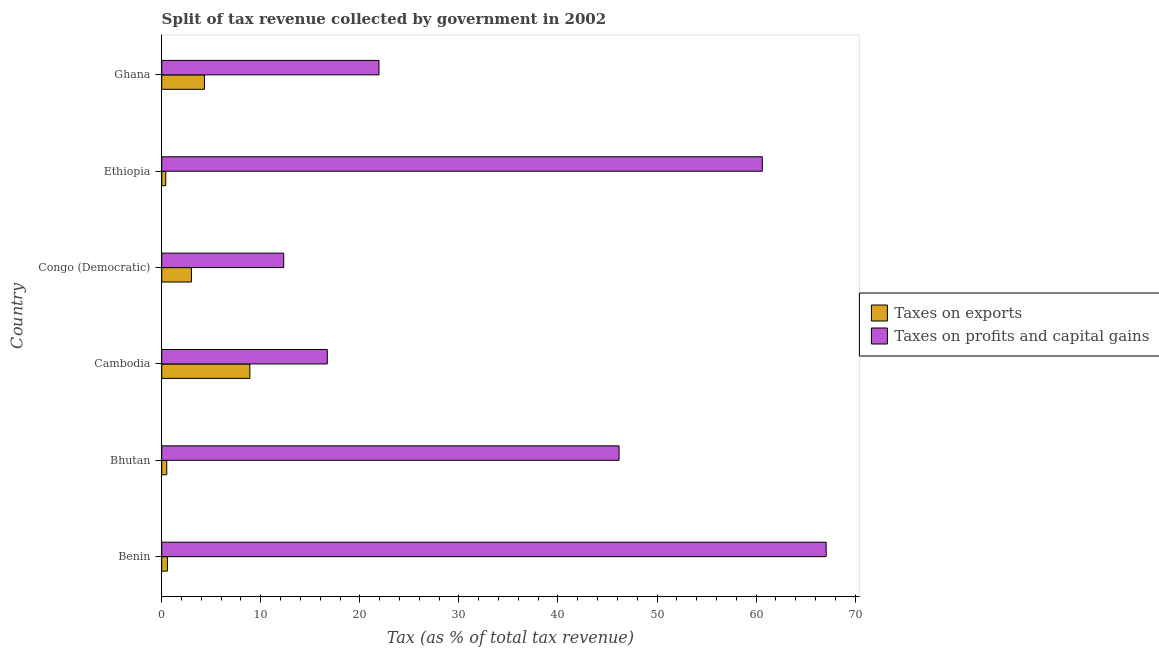How many different coloured bars are there?
Your answer should be compact. 2. Are the number of bars per tick equal to the number of legend labels?
Keep it short and to the point. Yes. Are the number of bars on each tick of the Y-axis equal?
Your response must be concise. Yes. What is the label of the 2nd group of bars from the top?
Offer a terse response. Ethiopia. In how many cases, is the number of bars for a given country not equal to the number of legend labels?
Offer a very short reply. 0. What is the percentage of revenue obtained from taxes on exports in Cambodia?
Provide a succinct answer. 8.9. Across all countries, what is the maximum percentage of revenue obtained from taxes on profits and capital gains?
Ensure brevity in your answer.  67.07. Across all countries, what is the minimum percentage of revenue obtained from taxes on exports?
Provide a succinct answer. 0.41. In which country was the percentage of revenue obtained from taxes on profits and capital gains maximum?
Give a very brief answer. Benin. In which country was the percentage of revenue obtained from taxes on exports minimum?
Keep it short and to the point. Ethiopia. What is the total percentage of revenue obtained from taxes on exports in the graph?
Make the answer very short. 17.71. What is the difference between the percentage of revenue obtained from taxes on profits and capital gains in Ethiopia and that in Ghana?
Offer a very short reply. 38.7. What is the difference between the percentage of revenue obtained from taxes on profits and capital gains in Benin and the percentage of revenue obtained from taxes on exports in Cambodia?
Your answer should be very brief. 58.18. What is the average percentage of revenue obtained from taxes on exports per country?
Provide a short and direct response. 2.95. What is the difference between the percentage of revenue obtained from taxes on profits and capital gains and percentage of revenue obtained from taxes on exports in Ghana?
Give a very brief answer. 17.62. What is the ratio of the percentage of revenue obtained from taxes on profits and capital gains in Cambodia to that in Congo (Democratic)?
Your answer should be very brief. 1.36. Is the difference between the percentage of revenue obtained from taxes on profits and capital gains in Benin and Ghana greater than the difference between the percentage of revenue obtained from taxes on exports in Benin and Ghana?
Offer a terse response. Yes. What is the difference between the highest and the second highest percentage of revenue obtained from taxes on profits and capital gains?
Your answer should be compact. 6.44. What is the difference between the highest and the lowest percentage of revenue obtained from taxes on exports?
Offer a terse response. 8.49. In how many countries, is the percentage of revenue obtained from taxes on profits and capital gains greater than the average percentage of revenue obtained from taxes on profits and capital gains taken over all countries?
Your answer should be very brief. 3. What does the 1st bar from the top in Cambodia represents?
Your answer should be compact. Taxes on profits and capital gains. What does the 2nd bar from the bottom in Cambodia represents?
Your answer should be very brief. Taxes on profits and capital gains. How many bars are there?
Ensure brevity in your answer.  12. Are all the bars in the graph horizontal?
Ensure brevity in your answer.  Yes. How many countries are there in the graph?
Keep it short and to the point. 6. Are the values on the major ticks of X-axis written in scientific E-notation?
Keep it short and to the point. No. Does the graph contain any zero values?
Give a very brief answer. No. Does the graph contain grids?
Give a very brief answer. No. Where does the legend appear in the graph?
Your response must be concise. Center right. How many legend labels are there?
Provide a succinct answer. 2. How are the legend labels stacked?
Make the answer very short. Vertical. What is the title of the graph?
Ensure brevity in your answer.  Split of tax revenue collected by government in 2002. Does "Transport services" appear as one of the legend labels in the graph?
Provide a short and direct response. No. What is the label or title of the X-axis?
Provide a short and direct response. Tax (as % of total tax revenue). What is the label or title of the Y-axis?
Provide a succinct answer. Country. What is the Tax (as % of total tax revenue) in Taxes on exports in Benin?
Ensure brevity in your answer.  0.58. What is the Tax (as % of total tax revenue) of Taxes on profits and capital gains in Benin?
Offer a terse response. 67.07. What is the Tax (as % of total tax revenue) in Taxes on exports in Bhutan?
Offer a very short reply. 0.51. What is the Tax (as % of total tax revenue) of Taxes on profits and capital gains in Bhutan?
Your response must be concise. 46.17. What is the Tax (as % of total tax revenue) of Taxes on exports in Cambodia?
Offer a terse response. 8.9. What is the Tax (as % of total tax revenue) of Taxes on profits and capital gains in Cambodia?
Make the answer very short. 16.72. What is the Tax (as % of total tax revenue) in Taxes on exports in Congo (Democratic)?
Provide a succinct answer. 3. What is the Tax (as % of total tax revenue) of Taxes on profits and capital gains in Congo (Democratic)?
Provide a succinct answer. 12.32. What is the Tax (as % of total tax revenue) of Taxes on exports in Ethiopia?
Provide a succinct answer. 0.41. What is the Tax (as % of total tax revenue) in Taxes on profits and capital gains in Ethiopia?
Provide a succinct answer. 60.63. What is the Tax (as % of total tax revenue) of Taxes on exports in Ghana?
Provide a short and direct response. 4.32. What is the Tax (as % of total tax revenue) in Taxes on profits and capital gains in Ghana?
Provide a succinct answer. 21.93. Across all countries, what is the maximum Tax (as % of total tax revenue) in Taxes on exports?
Offer a terse response. 8.9. Across all countries, what is the maximum Tax (as % of total tax revenue) of Taxes on profits and capital gains?
Provide a short and direct response. 67.07. Across all countries, what is the minimum Tax (as % of total tax revenue) in Taxes on exports?
Your answer should be very brief. 0.41. Across all countries, what is the minimum Tax (as % of total tax revenue) of Taxes on profits and capital gains?
Offer a very short reply. 12.32. What is the total Tax (as % of total tax revenue) of Taxes on exports in the graph?
Provide a succinct answer. 17.71. What is the total Tax (as % of total tax revenue) of Taxes on profits and capital gains in the graph?
Offer a very short reply. 224.83. What is the difference between the Tax (as % of total tax revenue) in Taxes on exports in Benin and that in Bhutan?
Provide a short and direct response. 0.07. What is the difference between the Tax (as % of total tax revenue) in Taxes on profits and capital gains in Benin and that in Bhutan?
Make the answer very short. 20.91. What is the difference between the Tax (as % of total tax revenue) in Taxes on exports in Benin and that in Cambodia?
Ensure brevity in your answer.  -8.32. What is the difference between the Tax (as % of total tax revenue) in Taxes on profits and capital gains in Benin and that in Cambodia?
Provide a short and direct response. 50.36. What is the difference between the Tax (as % of total tax revenue) of Taxes on exports in Benin and that in Congo (Democratic)?
Offer a very short reply. -2.43. What is the difference between the Tax (as % of total tax revenue) of Taxes on profits and capital gains in Benin and that in Congo (Democratic)?
Your answer should be compact. 54.76. What is the difference between the Tax (as % of total tax revenue) of Taxes on exports in Benin and that in Ethiopia?
Keep it short and to the point. 0.16. What is the difference between the Tax (as % of total tax revenue) of Taxes on profits and capital gains in Benin and that in Ethiopia?
Your answer should be compact. 6.44. What is the difference between the Tax (as % of total tax revenue) in Taxes on exports in Benin and that in Ghana?
Ensure brevity in your answer.  -3.74. What is the difference between the Tax (as % of total tax revenue) in Taxes on profits and capital gains in Benin and that in Ghana?
Provide a short and direct response. 45.14. What is the difference between the Tax (as % of total tax revenue) in Taxes on exports in Bhutan and that in Cambodia?
Provide a short and direct response. -8.39. What is the difference between the Tax (as % of total tax revenue) in Taxes on profits and capital gains in Bhutan and that in Cambodia?
Offer a very short reply. 29.45. What is the difference between the Tax (as % of total tax revenue) in Taxes on exports in Bhutan and that in Congo (Democratic)?
Give a very brief answer. -2.49. What is the difference between the Tax (as % of total tax revenue) in Taxes on profits and capital gains in Bhutan and that in Congo (Democratic)?
Provide a short and direct response. 33.85. What is the difference between the Tax (as % of total tax revenue) of Taxes on exports in Bhutan and that in Ethiopia?
Provide a succinct answer. 0.1. What is the difference between the Tax (as % of total tax revenue) in Taxes on profits and capital gains in Bhutan and that in Ethiopia?
Your response must be concise. -14.46. What is the difference between the Tax (as % of total tax revenue) of Taxes on exports in Bhutan and that in Ghana?
Ensure brevity in your answer.  -3.81. What is the difference between the Tax (as % of total tax revenue) in Taxes on profits and capital gains in Bhutan and that in Ghana?
Ensure brevity in your answer.  24.23. What is the difference between the Tax (as % of total tax revenue) of Taxes on exports in Cambodia and that in Congo (Democratic)?
Provide a short and direct response. 5.89. What is the difference between the Tax (as % of total tax revenue) of Taxes on profits and capital gains in Cambodia and that in Congo (Democratic)?
Your answer should be compact. 4.4. What is the difference between the Tax (as % of total tax revenue) in Taxes on exports in Cambodia and that in Ethiopia?
Your response must be concise. 8.49. What is the difference between the Tax (as % of total tax revenue) in Taxes on profits and capital gains in Cambodia and that in Ethiopia?
Make the answer very short. -43.91. What is the difference between the Tax (as % of total tax revenue) of Taxes on exports in Cambodia and that in Ghana?
Offer a very short reply. 4.58. What is the difference between the Tax (as % of total tax revenue) in Taxes on profits and capital gains in Cambodia and that in Ghana?
Offer a terse response. -5.22. What is the difference between the Tax (as % of total tax revenue) of Taxes on exports in Congo (Democratic) and that in Ethiopia?
Keep it short and to the point. 2.59. What is the difference between the Tax (as % of total tax revenue) of Taxes on profits and capital gains in Congo (Democratic) and that in Ethiopia?
Make the answer very short. -48.31. What is the difference between the Tax (as % of total tax revenue) of Taxes on exports in Congo (Democratic) and that in Ghana?
Your answer should be compact. -1.31. What is the difference between the Tax (as % of total tax revenue) in Taxes on profits and capital gains in Congo (Democratic) and that in Ghana?
Your response must be concise. -9.62. What is the difference between the Tax (as % of total tax revenue) of Taxes on exports in Ethiopia and that in Ghana?
Ensure brevity in your answer.  -3.9. What is the difference between the Tax (as % of total tax revenue) in Taxes on profits and capital gains in Ethiopia and that in Ghana?
Offer a very short reply. 38.7. What is the difference between the Tax (as % of total tax revenue) in Taxes on exports in Benin and the Tax (as % of total tax revenue) in Taxes on profits and capital gains in Bhutan?
Make the answer very short. -45.59. What is the difference between the Tax (as % of total tax revenue) of Taxes on exports in Benin and the Tax (as % of total tax revenue) of Taxes on profits and capital gains in Cambodia?
Provide a succinct answer. -16.14. What is the difference between the Tax (as % of total tax revenue) of Taxes on exports in Benin and the Tax (as % of total tax revenue) of Taxes on profits and capital gains in Congo (Democratic)?
Your answer should be compact. -11.74. What is the difference between the Tax (as % of total tax revenue) of Taxes on exports in Benin and the Tax (as % of total tax revenue) of Taxes on profits and capital gains in Ethiopia?
Your answer should be compact. -60.05. What is the difference between the Tax (as % of total tax revenue) of Taxes on exports in Benin and the Tax (as % of total tax revenue) of Taxes on profits and capital gains in Ghana?
Offer a very short reply. -21.36. What is the difference between the Tax (as % of total tax revenue) of Taxes on exports in Bhutan and the Tax (as % of total tax revenue) of Taxes on profits and capital gains in Cambodia?
Your answer should be compact. -16.21. What is the difference between the Tax (as % of total tax revenue) of Taxes on exports in Bhutan and the Tax (as % of total tax revenue) of Taxes on profits and capital gains in Congo (Democratic)?
Your answer should be compact. -11.81. What is the difference between the Tax (as % of total tax revenue) of Taxes on exports in Bhutan and the Tax (as % of total tax revenue) of Taxes on profits and capital gains in Ethiopia?
Make the answer very short. -60.12. What is the difference between the Tax (as % of total tax revenue) of Taxes on exports in Bhutan and the Tax (as % of total tax revenue) of Taxes on profits and capital gains in Ghana?
Give a very brief answer. -21.42. What is the difference between the Tax (as % of total tax revenue) in Taxes on exports in Cambodia and the Tax (as % of total tax revenue) in Taxes on profits and capital gains in Congo (Democratic)?
Keep it short and to the point. -3.42. What is the difference between the Tax (as % of total tax revenue) of Taxes on exports in Cambodia and the Tax (as % of total tax revenue) of Taxes on profits and capital gains in Ethiopia?
Your answer should be compact. -51.73. What is the difference between the Tax (as % of total tax revenue) in Taxes on exports in Cambodia and the Tax (as % of total tax revenue) in Taxes on profits and capital gains in Ghana?
Ensure brevity in your answer.  -13.04. What is the difference between the Tax (as % of total tax revenue) in Taxes on exports in Congo (Democratic) and the Tax (as % of total tax revenue) in Taxes on profits and capital gains in Ethiopia?
Keep it short and to the point. -57.63. What is the difference between the Tax (as % of total tax revenue) in Taxes on exports in Congo (Democratic) and the Tax (as % of total tax revenue) in Taxes on profits and capital gains in Ghana?
Offer a very short reply. -18.93. What is the difference between the Tax (as % of total tax revenue) of Taxes on exports in Ethiopia and the Tax (as % of total tax revenue) of Taxes on profits and capital gains in Ghana?
Your answer should be compact. -21.52. What is the average Tax (as % of total tax revenue) in Taxes on exports per country?
Provide a short and direct response. 2.95. What is the average Tax (as % of total tax revenue) in Taxes on profits and capital gains per country?
Ensure brevity in your answer.  37.47. What is the difference between the Tax (as % of total tax revenue) in Taxes on exports and Tax (as % of total tax revenue) in Taxes on profits and capital gains in Benin?
Provide a succinct answer. -66.5. What is the difference between the Tax (as % of total tax revenue) of Taxes on exports and Tax (as % of total tax revenue) of Taxes on profits and capital gains in Bhutan?
Provide a succinct answer. -45.66. What is the difference between the Tax (as % of total tax revenue) in Taxes on exports and Tax (as % of total tax revenue) in Taxes on profits and capital gains in Cambodia?
Offer a terse response. -7.82. What is the difference between the Tax (as % of total tax revenue) of Taxes on exports and Tax (as % of total tax revenue) of Taxes on profits and capital gains in Congo (Democratic)?
Offer a terse response. -9.31. What is the difference between the Tax (as % of total tax revenue) in Taxes on exports and Tax (as % of total tax revenue) in Taxes on profits and capital gains in Ethiopia?
Ensure brevity in your answer.  -60.22. What is the difference between the Tax (as % of total tax revenue) of Taxes on exports and Tax (as % of total tax revenue) of Taxes on profits and capital gains in Ghana?
Provide a succinct answer. -17.62. What is the ratio of the Tax (as % of total tax revenue) of Taxes on exports in Benin to that in Bhutan?
Offer a terse response. 1.13. What is the ratio of the Tax (as % of total tax revenue) in Taxes on profits and capital gains in Benin to that in Bhutan?
Provide a succinct answer. 1.45. What is the ratio of the Tax (as % of total tax revenue) in Taxes on exports in Benin to that in Cambodia?
Your answer should be compact. 0.06. What is the ratio of the Tax (as % of total tax revenue) in Taxes on profits and capital gains in Benin to that in Cambodia?
Your response must be concise. 4.01. What is the ratio of the Tax (as % of total tax revenue) in Taxes on exports in Benin to that in Congo (Democratic)?
Provide a short and direct response. 0.19. What is the ratio of the Tax (as % of total tax revenue) in Taxes on profits and capital gains in Benin to that in Congo (Democratic)?
Ensure brevity in your answer.  5.45. What is the ratio of the Tax (as % of total tax revenue) in Taxes on exports in Benin to that in Ethiopia?
Offer a very short reply. 1.4. What is the ratio of the Tax (as % of total tax revenue) in Taxes on profits and capital gains in Benin to that in Ethiopia?
Make the answer very short. 1.11. What is the ratio of the Tax (as % of total tax revenue) of Taxes on exports in Benin to that in Ghana?
Give a very brief answer. 0.13. What is the ratio of the Tax (as % of total tax revenue) of Taxes on profits and capital gains in Benin to that in Ghana?
Your response must be concise. 3.06. What is the ratio of the Tax (as % of total tax revenue) in Taxes on exports in Bhutan to that in Cambodia?
Offer a terse response. 0.06. What is the ratio of the Tax (as % of total tax revenue) of Taxes on profits and capital gains in Bhutan to that in Cambodia?
Provide a short and direct response. 2.76. What is the ratio of the Tax (as % of total tax revenue) in Taxes on exports in Bhutan to that in Congo (Democratic)?
Keep it short and to the point. 0.17. What is the ratio of the Tax (as % of total tax revenue) of Taxes on profits and capital gains in Bhutan to that in Congo (Democratic)?
Keep it short and to the point. 3.75. What is the ratio of the Tax (as % of total tax revenue) in Taxes on exports in Bhutan to that in Ethiopia?
Your response must be concise. 1.24. What is the ratio of the Tax (as % of total tax revenue) of Taxes on profits and capital gains in Bhutan to that in Ethiopia?
Your response must be concise. 0.76. What is the ratio of the Tax (as % of total tax revenue) in Taxes on exports in Bhutan to that in Ghana?
Your answer should be compact. 0.12. What is the ratio of the Tax (as % of total tax revenue) of Taxes on profits and capital gains in Bhutan to that in Ghana?
Your answer should be compact. 2.1. What is the ratio of the Tax (as % of total tax revenue) of Taxes on exports in Cambodia to that in Congo (Democratic)?
Your response must be concise. 2.96. What is the ratio of the Tax (as % of total tax revenue) of Taxes on profits and capital gains in Cambodia to that in Congo (Democratic)?
Ensure brevity in your answer.  1.36. What is the ratio of the Tax (as % of total tax revenue) of Taxes on exports in Cambodia to that in Ethiopia?
Offer a very short reply. 21.62. What is the ratio of the Tax (as % of total tax revenue) in Taxes on profits and capital gains in Cambodia to that in Ethiopia?
Offer a terse response. 0.28. What is the ratio of the Tax (as % of total tax revenue) in Taxes on exports in Cambodia to that in Ghana?
Offer a very short reply. 2.06. What is the ratio of the Tax (as % of total tax revenue) in Taxes on profits and capital gains in Cambodia to that in Ghana?
Make the answer very short. 0.76. What is the ratio of the Tax (as % of total tax revenue) in Taxes on exports in Congo (Democratic) to that in Ethiopia?
Your answer should be very brief. 7.3. What is the ratio of the Tax (as % of total tax revenue) of Taxes on profits and capital gains in Congo (Democratic) to that in Ethiopia?
Make the answer very short. 0.2. What is the ratio of the Tax (as % of total tax revenue) in Taxes on exports in Congo (Democratic) to that in Ghana?
Your response must be concise. 0.7. What is the ratio of the Tax (as % of total tax revenue) of Taxes on profits and capital gains in Congo (Democratic) to that in Ghana?
Your response must be concise. 0.56. What is the ratio of the Tax (as % of total tax revenue) of Taxes on exports in Ethiopia to that in Ghana?
Make the answer very short. 0.1. What is the ratio of the Tax (as % of total tax revenue) in Taxes on profits and capital gains in Ethiopia to that in Ghana?
Your answer should be very brief. 2.76. What is the difference between the highest and the second highest Tax (as % of total tax revenue) of Taxes on exports?
Offer a terse response. 4.58. What is the difference between the highest and the second highest Tax (as % of total tax revenue) of Taxes on profits and capital gains?
Make the answer very short. 6.44. What is the difference between the highest and the lowest Tax (as % of total tax revenue) of Taxes on exports?
Provide a short and direct response. 8.49. What is the difference between the highest and the lowest Tax (as % of total tax revenue) of Taxes on profits and capital gains?
Ensure brevity in your answer.  54.76. 